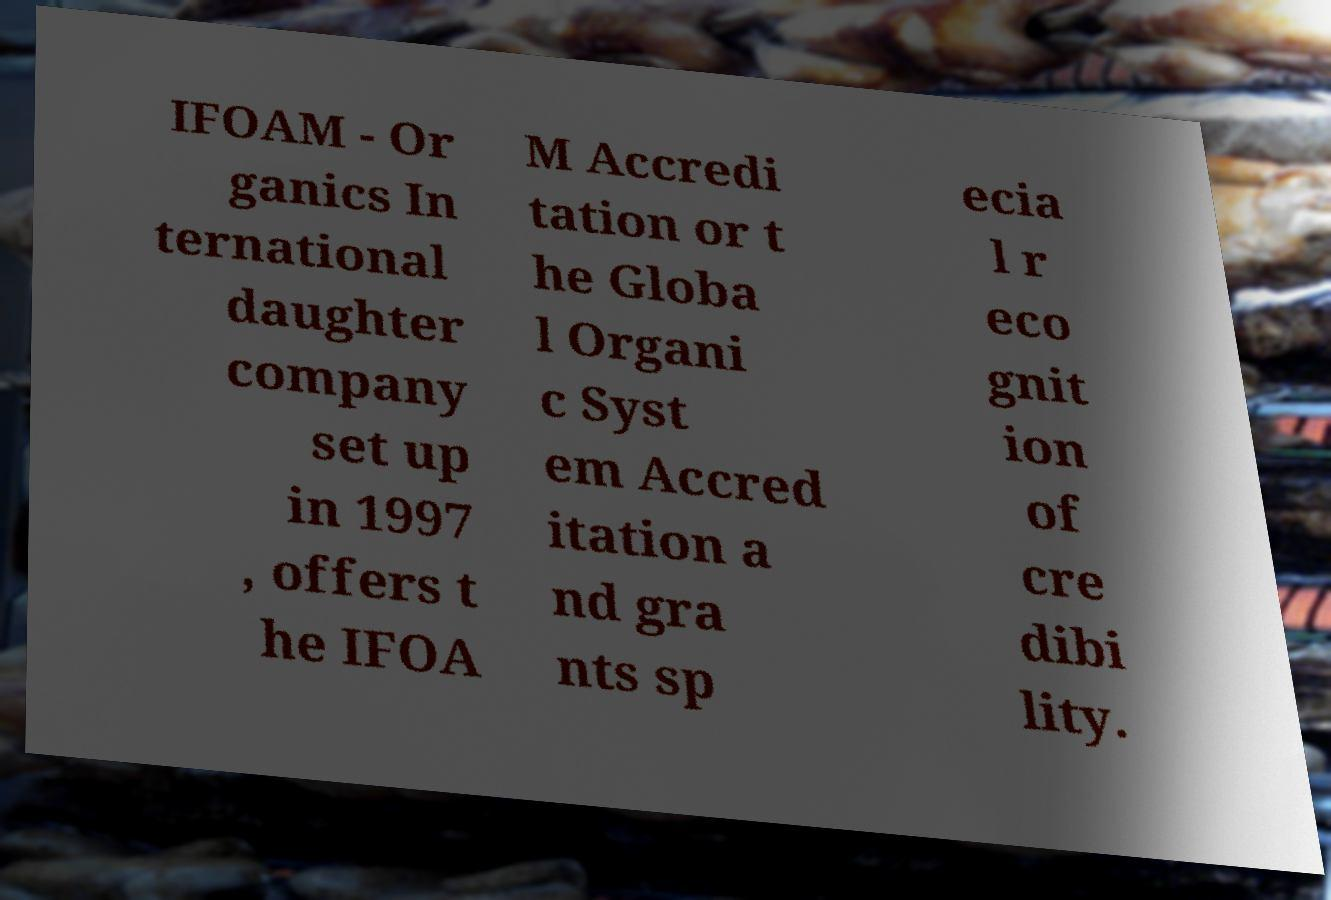Can you read and provide the text displayed in the image?This photo seems to have some interesting text. Can you extract and type it out for me? IFOAM - Or ganics In ternational daughter company set up in 1997 , offers t he IFOA M Accredi tation or t he Globa l Organi c Syst em Accred itation a nd gra nts sp ecia l r eco gnit ion of cre dibi lity. 